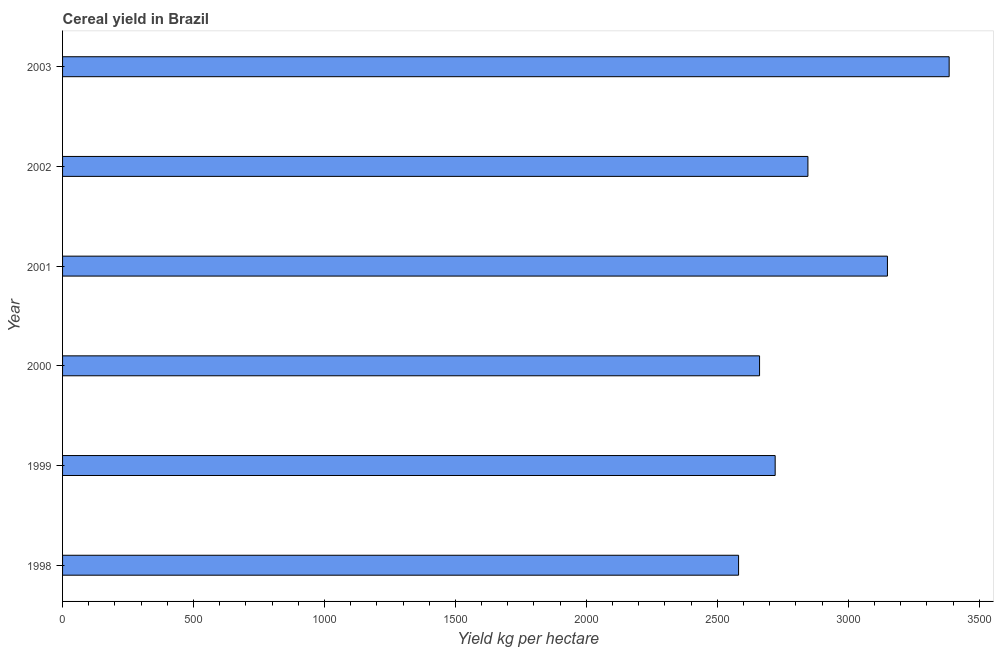What is the title of the graph?
Ensure brevity in your answer.  Cereal yield in Brazil. What is the label or title of the X-axis?
Make the answer very short. Yield kg per hectare. What is the label or title of the Y-axis?
Offer a terse response. Year. What is the cereal yield in 1998?
Make the answer very short. 2581.25. Across all years, what is the maximum cereal yield?
Your answer should be very brief. 3385.3. Across all years, what is the minimum cereal yield?
Offer a very short reply. 2581.25. What is the sum of the cereal yield?
Give a very brief answer. 1.73e+04. What is the difference between the cereal yield in 1998 and 2000?
Provide a succinct answer. -80.1. What is the average cereal yield per year?
Give a very brief answer. 2890.75. What is the median cereal yield?
Offer a very short reply. 2783.49. Do a majority of the years between 1998 and 2001 (inclusive) have cereal yield greater than 1200 kg per hectare?
Offer a terse response. Yes. What is the ratio of the cereal yield in 1998 to that in 2001?
Offer a terse response. 0.82. Is the difference between the cereal yield in 1999 and 2002 greater than the difference between any two years?
Your response must be concise. No. What is the difference between the highest and the second highest cereal yield?
Ensure brevity in your answer.  235.7. Is the sum of the cereal yield in 1999 and 2003 greater than the maximum cereal yield across all years?
Give a very brief answer. Yes. What is the difference between the highest and the lowest cereal yield?
Ensure brevity in your answer.  804.05. In how many years, is the cereal yield greater than the average cereal yield taken over all years?
Ensure brevity in your answer.  2. What is the Yield kg per hectare of 1998?
Provide a succinct answer. 2581.25. What is the Yield kg per hectare of 1999?
Your answer should be compact. 2720.95. What is the Yield kg per hectare of 2000?
Keep it short and to the point. 2661.35. What is the Yield kg per hectare of 2001?
Your response must be concise. 3149.6. What is the Yield kg per hectare of 2002?
Provide a short and direct response. 2846.02. What is the Yield kg per hectare in 2003?
Give a very brief answer. 3385.3. What is the difference between the Yield kg per hectare in 1998 and 1999?
Give a very brief answer. -139.7. What is the difference between the Yield kg per hectare in 1998 and 2000?
Your response must be concise. -80.1. What is the difference between the Yield kg per hectare in 1998 and 2001?
Offer a terse response. -568.35. What is the difference between the Yield kg per hectare in 1998 and 2002?
Your answer should be compact. -264.77. What is the difference between the Yield kg per hectare in 1998 and 2003?
Provide a short and direct response. -804.05. What is the difference between the Yield kg per hectare in 1999 and 2000?
Provide a short and direct response. 59.6. What is the difference between the Yield kg per hectare in 1999 and 2001?
Your answer should be compact. -428.65. What is the difference between the Yield kg per hectare in 1999 and 2002?
Keep it short and to the point. -125.07. What is the difference between the Yield kg per hectare in 1999 and 2003?
Offer a terse response. -664.35. What is the difference between the Yield kg per hectare in 2000 and 2001?
Provide a succinct answer. -488.25. What is the difference between the Yield kg per hectare in 2000 and 2002?
Make the answer very short. -184.67. What is the difference between the Yield kg per hectare in 2000 and 2003?
Offer a very short reply. -723.95. What is the difference between the Yield kg per hectare in 2001 and 2002?
Provide a short and direct response. 303.58. What is the difference between the Yield kg per hectare in 2001 and 2003?
Provide a short and direct response. -235.7. What is the difference between the Yield kg per hectare in 2002 and 2003?
Your response must be concise. -539.28. What is the ratio of the Yield kg per hectare in 1998 to that in 1999?
Ensure brevity in your answer.  0.95. What is the ratio of the Yield kg per hectare in 1998 to that in 2000?
Ensure brevity in your answer.  0.97. What is the ratio of the Yield kg per hectare in 1998 to that in 2001?
Your answer should be compact. 0.82. What is the ratio of the Yield kg per hectare in 1998 to that in 2002?
Your response must be concise. 0.91. What is the ratio of the Yield kg per hectare in 1998 to that in 2003?
Provide a succinct answer. 0.76. What is the ratio of the Yield kg per hectare in 1999 to that in 2000?
Your answer should be very brief. 1.02. What is the ratio of the Yield kg per hectare in 1999 to that in 2001?
Offer a terse response. 0.86. What is the ratio of the Yield kg per hectare in 1999 to that in 2002?
Provide a succinct answer. 0.96. What is the ratio of the Yield kg per hectare in 1999 to that in 2003?
Give a very brief answer. 0.8. What is the ratio of the Yield kg per hectare in 2000 to that in 2001?
Give a very brief answer. 0.84. What is the ratio of the Yield kg per hectare in 2000 to that in 2002?
Keep it short and to the point. 0.94. What is the ratio of the Yield kg per hectare in 2000 to that in 2003?
Provide a short and direct response. 0.79. What is the ratio of the Yield kg per hectare in 2001 to that in 2002?
Your answer should be very brief. 1.11. What is the ratio of the Yield kg per hectare in 2002 to that in 2003?
Ensure brevity in your answer.  0.84. 